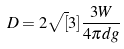Convert formula to latex. <formula><loc_0><loc_0><loc_500><loc_500>D = 2 \sqrt { [ } 3 ] { \frac { 3 W } { 4 \pi d g } }</formula> 